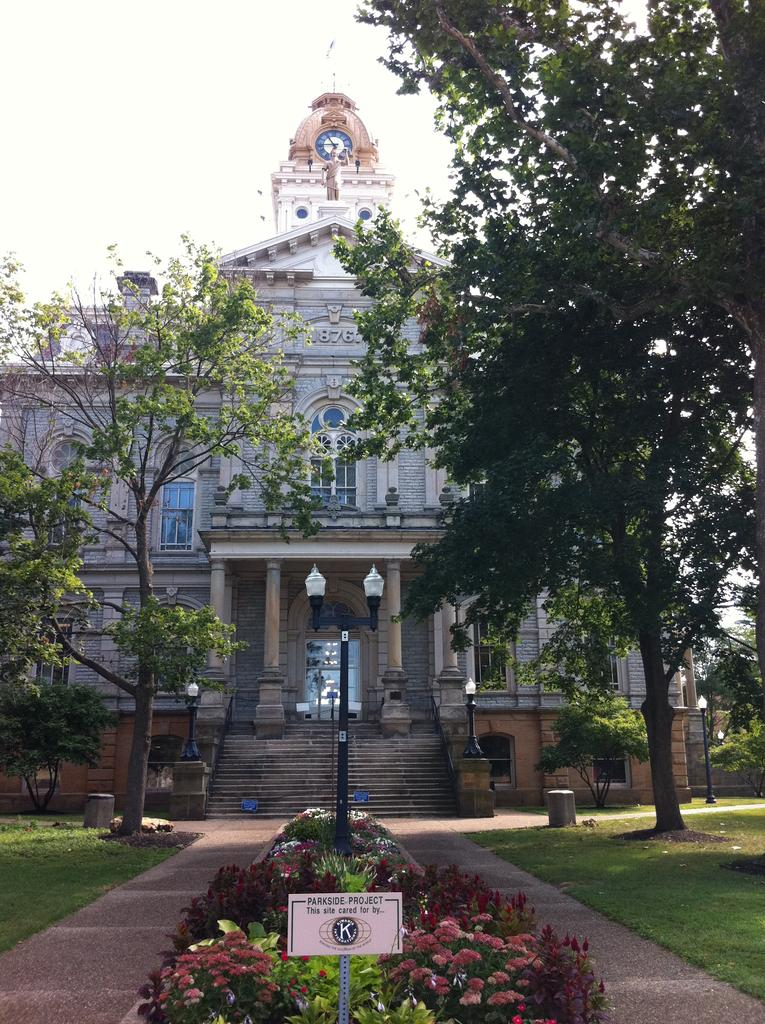<image>
Provide a brief description of the given image. A parkside project sign is coming out of the ground, in a small garden in front of a very large building. 